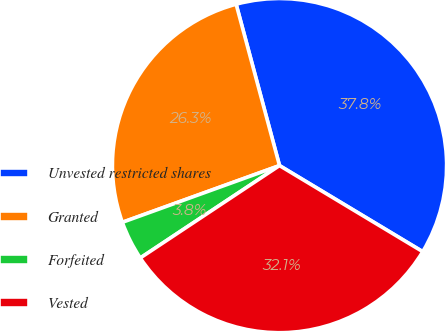Convert chart. <chart><loc_0><loc_0><loc_500><loc_500><pie_chart><fcel>Unvested restricted shares<fcel>Granted<fcel>Forfeited<fcel>Vested<nl><fcel>37.79%<fcel>26.33%<fcel>3.81%<fcel>32.06%<nl></chart> 